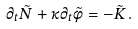Convert formula to latex. <formula><loc_0><loc_0><loc_500><loc_500>\partial _ { t } \tilde { N } + \kappa \partial _ { t } \tilde { \phi } = - \tilde { K } \, .</formula> 